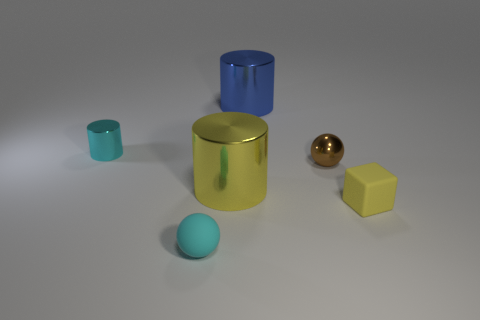There is a matte thing that is the same size as the matte block; what is its shape? The object that is the same size as the matte block is a sphere. The matte finish on both items gives them a non-reflective surface, enhancing the similarity in size and contrasting their distinct shapes. 